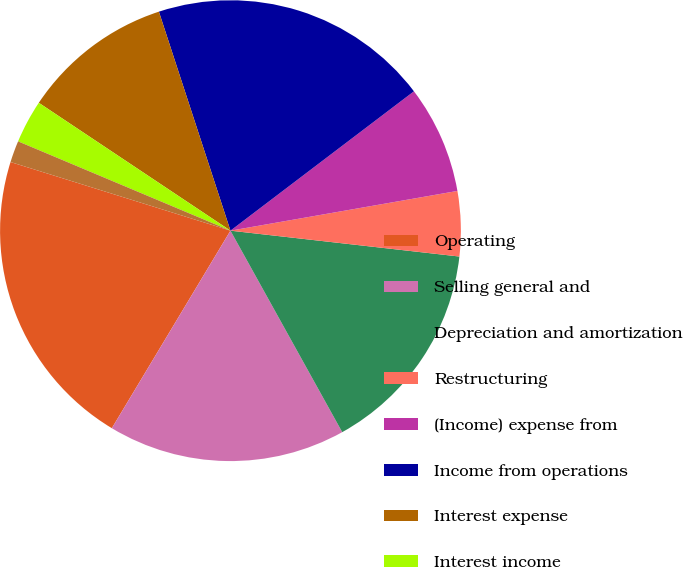<chart> <loc_0><loc_0><loc_500><loc_500><pie_chart><fcel>Operating<fcel>Selling general and<fcel>Depreciation and amortization<fcel>Restructuring<fcel>(Income) expense from<fcel>Income from operations<fcel>Interest expense<fcel>Interest income<fcel>Equity in net losses of<fcel>Other net<nl><fcel>21.21%<fcel>16.67%<fcel>15.15%<fcel>4.55%<fcel>7.58%<fcel>19.69%<fcel>10.61%<fcel>3.03%<fcel>1.52%<fcel>0.0%<nl></chart> 